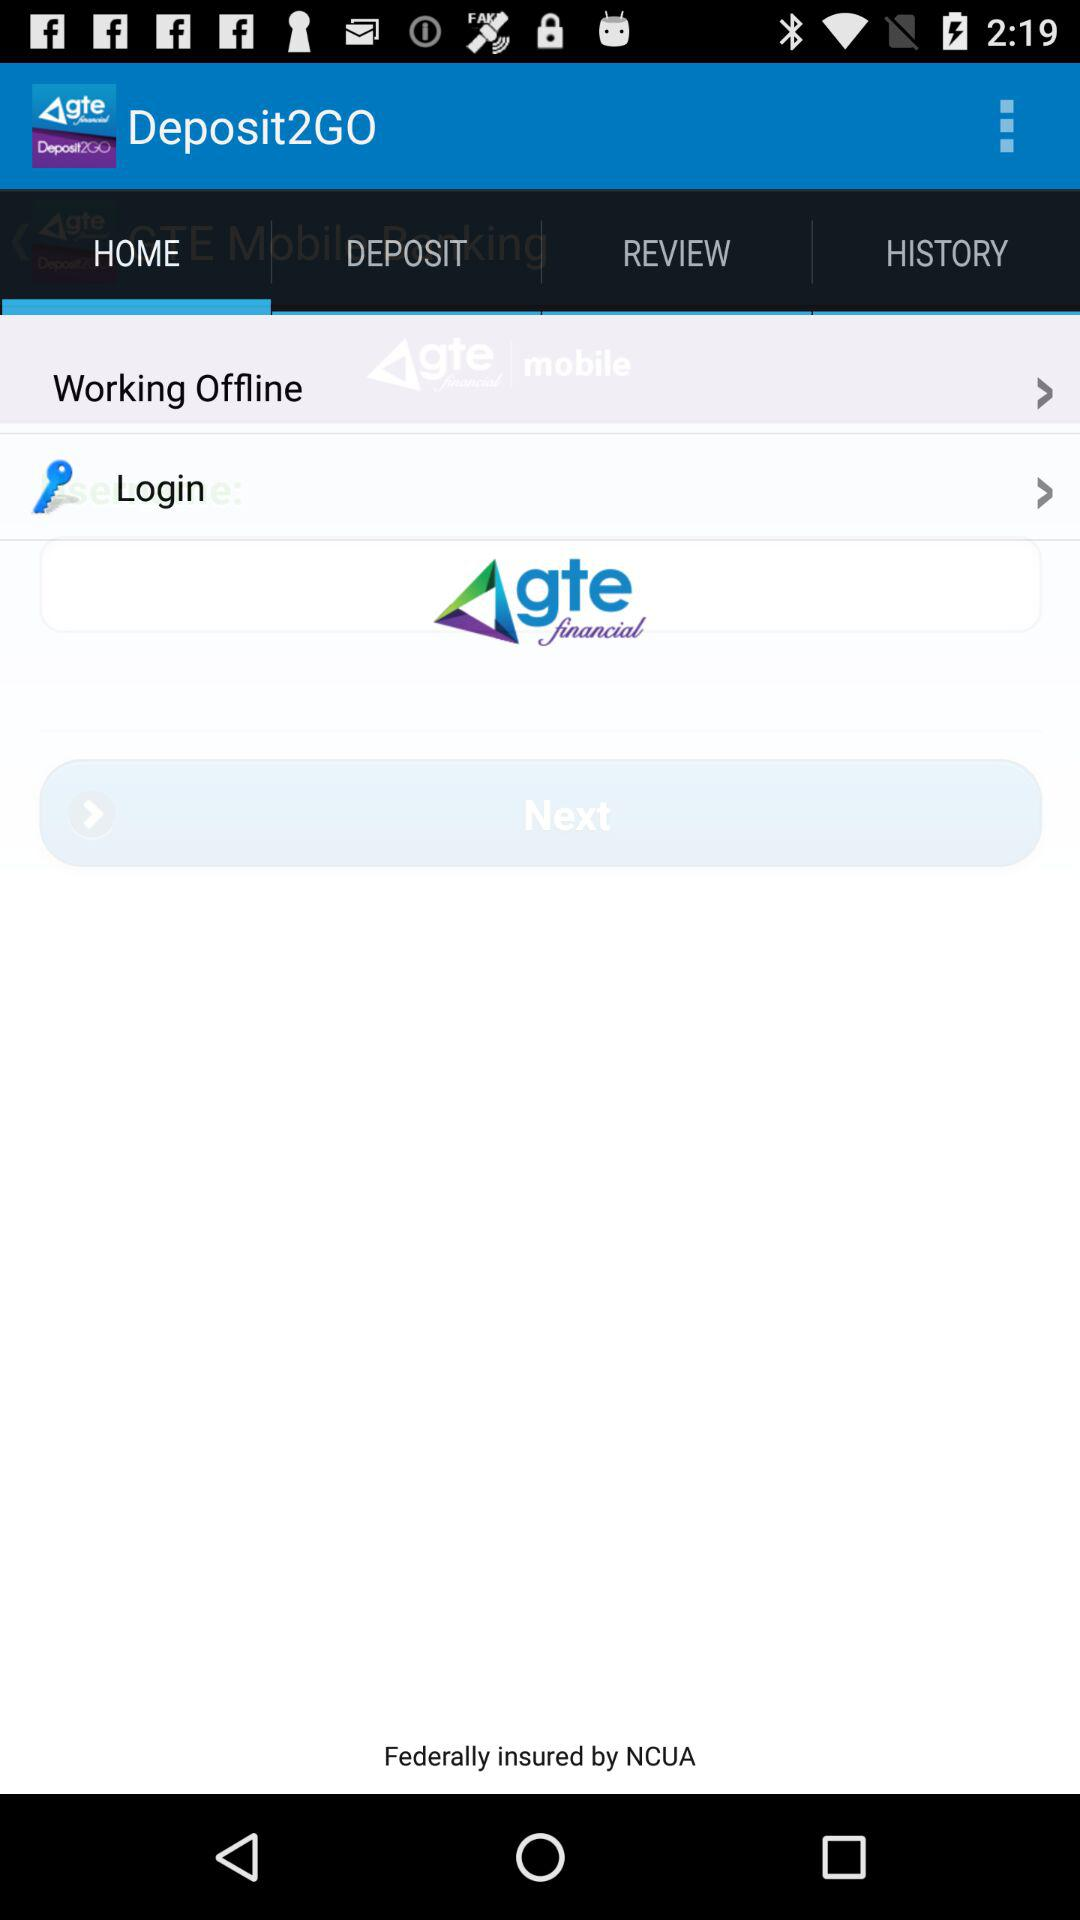What is the application name? The application name is "Deposit2GO". 